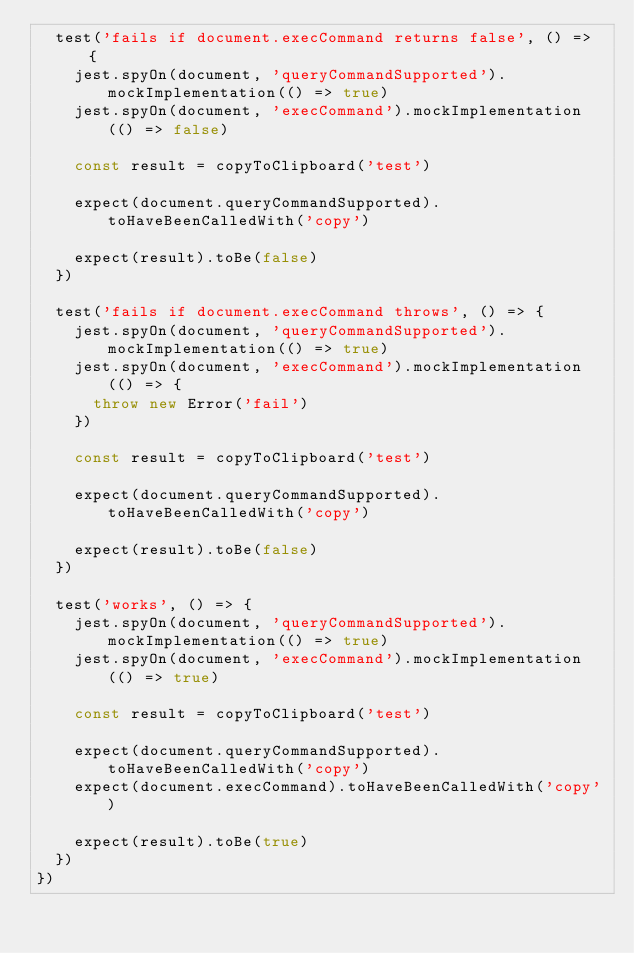Convert code to text. <code><loc_0><loc_0><loc_500><loc_500><_JavaScript_>  test('fails if document.execCommand returns false', () => {
    jest.spyOn(document, 'queryCommandSupported').mockImplementation(() => true)
    jest.spyOn(document, 'execCommand').mockImplementation(() => false)

    const result = copyToClipboard('test')

    expect(document.queryCommandSupported).toHaveBeenCalledWith('copy')

    expect(result).toBe(false)
  })

  test('fails if document.execCommand throws', () => {
    jest.spyOn(document, 'queryCommandSupported').mockImplementation(() => true)
    jest.spyOn(document, 'execCommand').mockImplementation(() => {
      throw new Error('fail')
    })

    const result = copyToClipboard('test')

    expect(document.queryCommandSupported).toHaveBeenCalledWith('copy')

    expect(result).toBe(false)
  })

  test('works', () => {
    jest.spyOn(document, 'queryCommandSupported').mockImplementation(() => true)
    jest.spyOn(document, 'execCommand').mockImplementation(() => true)

    const result = copyToClipboard('test')

    expect(document.queryCommandSupported).toHaveBeenCalledWith('copy')
    expect(document.execCommand).toHaveBeenCalledWith('copy')

    expect(result).toBe(true)
  })
})
</code> 